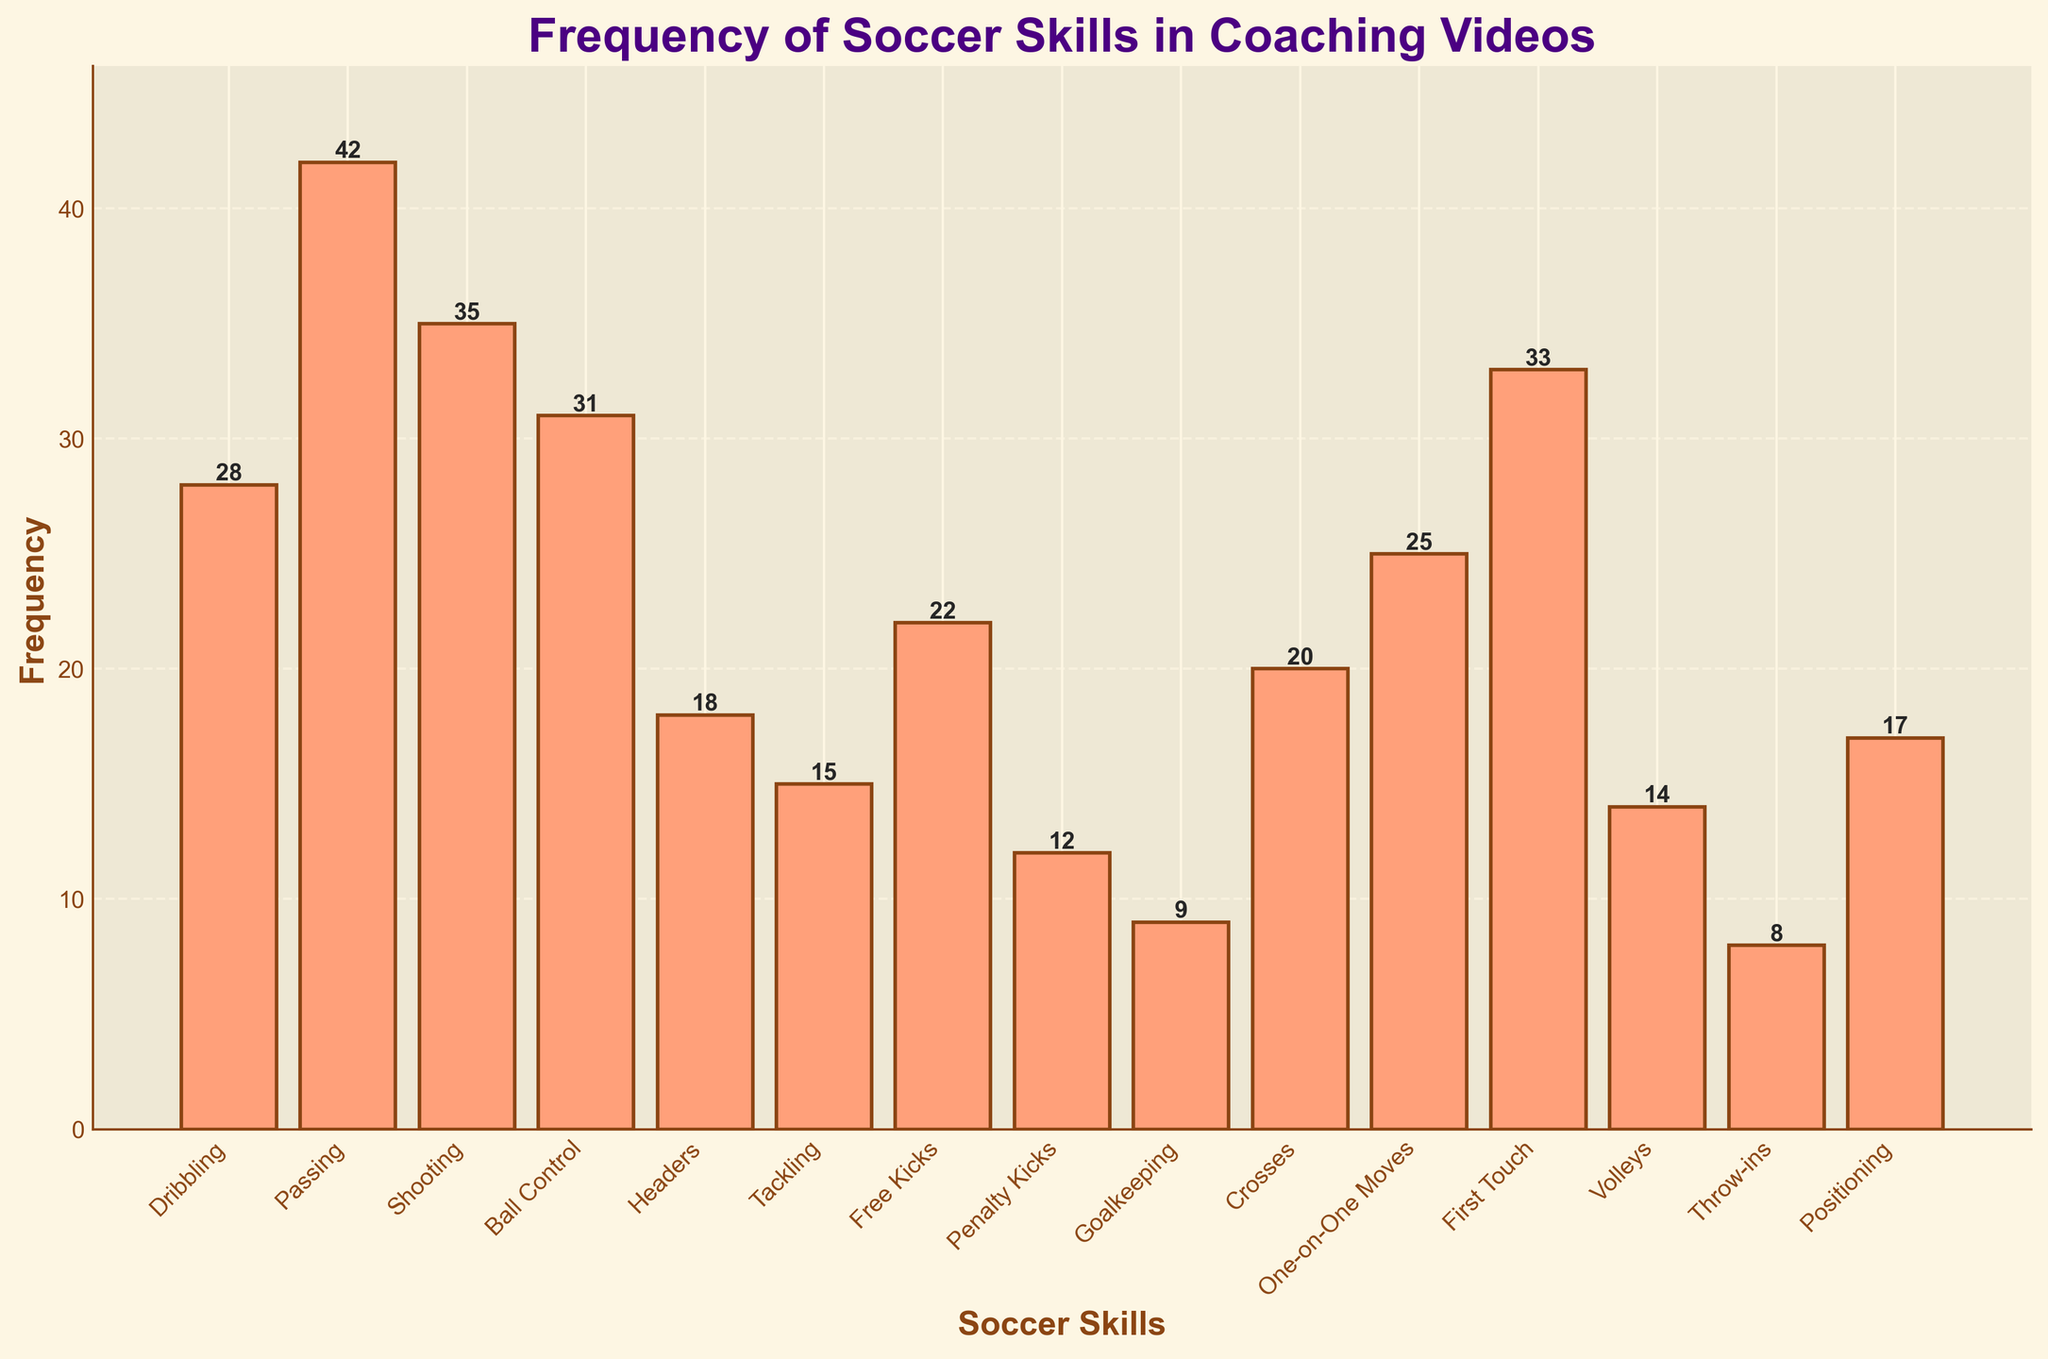What's the title of the histogram? The title of the histogram is displayed at the top of the figure. By examining the image, we can see it clearly.
Answer: Frequency of Soccer Skills in Coaching Videos What's the highest frequency for any soccer skill, and which skill does it correspond to? By identifying and comparing the heights of the bars in the histogram, the tallest bar corresponds to the highest frequency. The label under this bar tells us the skill.
Answer: Passing, 42 How many different soccer skills are demonstrated in the coaching videos? Count the number of distinct bars in the histogram. Each bar represents a unique soccer skill.
Answer: 15 Which skill has the lowest frequency and what is its value? Find the shortest bar in the histogram and read its corresponding label and height.
Answer: Throw-ins, 8 What is the combined frequency of Shooting and First Touch? Identify the bars for Shooting and First Touch, note their heights, and add them together (35 + 33).
Answer: 68 How much more frequent are Passing demonstrations compared to Headers? Find the frequencies of Passing and Headers, then calculate the difference (42 - 18).
Answer: 24 Which skill category has a frequency closest to 20? Inspect the heights of the bars and find the one that is nearest to 20, then read its label.
Answer: Crosses Are there more demonstrations of Free Kicks or Penalty Kicks? Compare the heights of the bars for Free Kicks and Penalty Kicks. Free Kicks has a taller bar.
Answer: Free Kicks What is the average frequency of the skills demonstrated? Sum up all the frequencies and divide by the number of skills (28 + 42 + 35 + 31 + 18 + 15 + 22 + 12 + 9 + 20 + 25 + 33 + 14 + 8 + 17 = 329, then 329/15).
Answer: 21.93 Which skill has the closest frequency to the median frequency, and what is that frequency? To find the median, we need to list the frequencies in ascending order and find the middle value. The frequencies in order are: 8, 9, 12, 14, 15, 17, 18, 20, 22, 25, 28, 31, 33, 35, 42. The median frequency is the 8th value (20). Thus, the skill with a frequency closest to 20 is Crosses.
Answer: Crosses, 20 